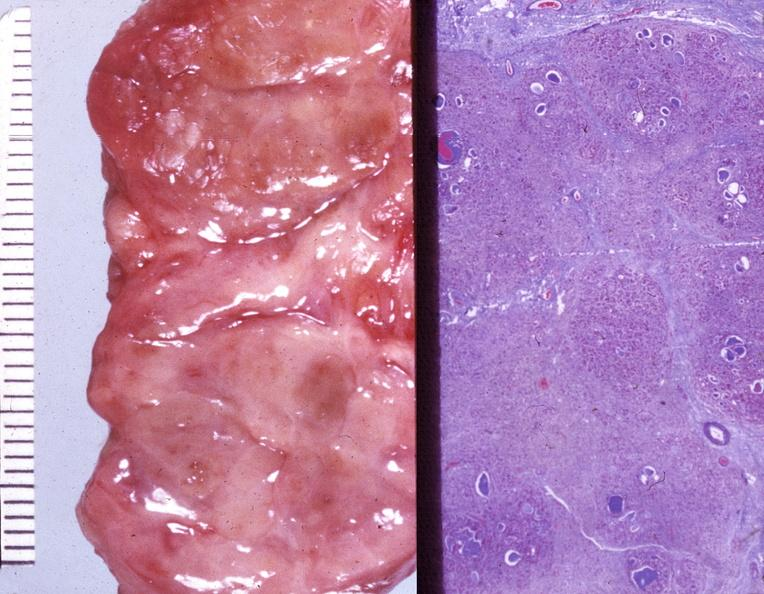s chronic ischemia present?
Answer the question using a single word or phrase. No 